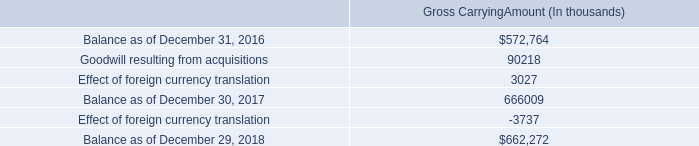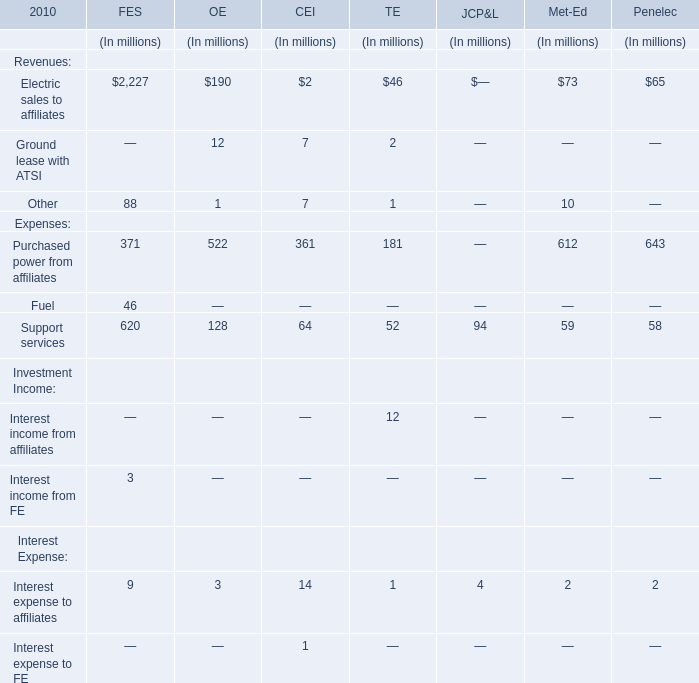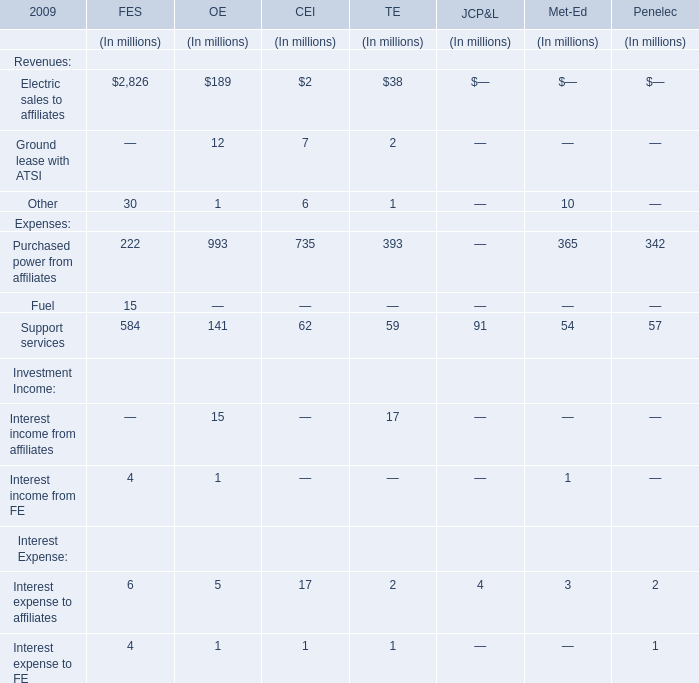for acquisitions in 2017 what percentage of recorded a total acquired intangible assets was goodwill? 
Computations: (76.4 / 90.2)
Answer: 0.84701. 